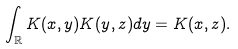Convert formula to latex. <formula><loc_0><loc_0><loc_500><loc_500>\int _ { \mathbb { R } } K ( x , y ) K ( y , z ) d y = K ( x , z ) .</formula> 